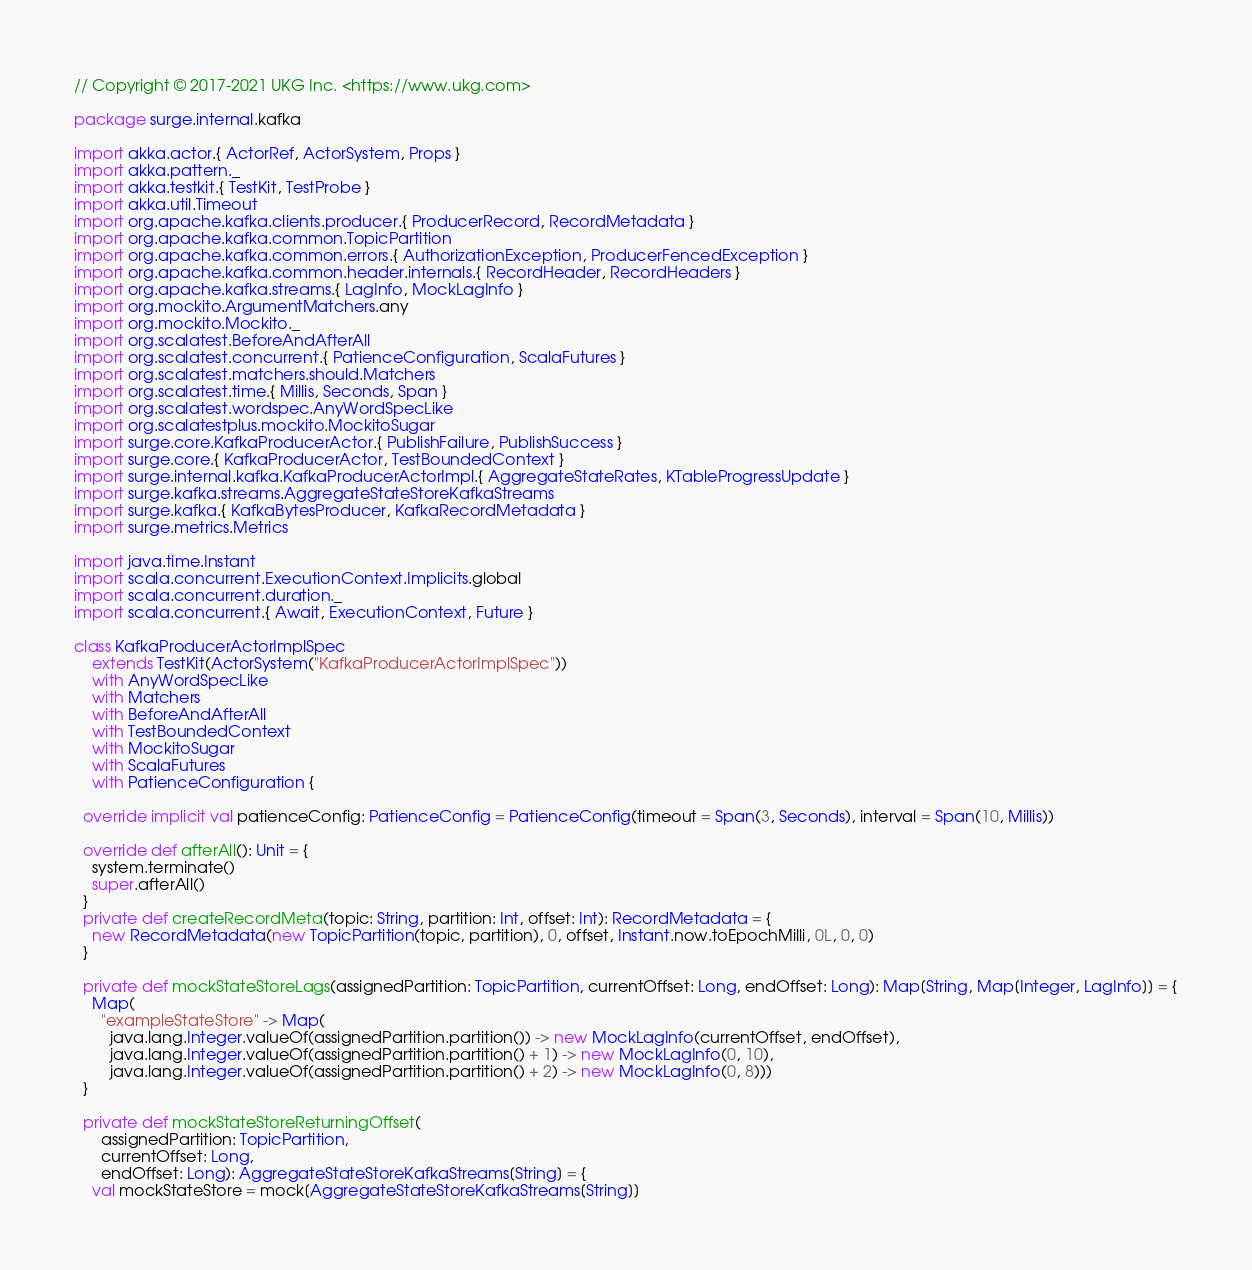<code> <loc_0><loc_0><loc_500><loc_500><_Scala_>// Copyright © 2017-2021 UKG Inc. <https://www.ukg.com>

package surge.internal.kafka

import akka.actor.{ ActorRef, ActorSystem, Props }
import akka.pattern._
import akka.testkit.{ TestKit, TestProbe }
import akka.util.Timeout
import org.apache.kafka.clients.producer.{ ProducerRecord, RecordMetadata }
import org.apache.kafka.common.TopicPartition
import org.apache.kafka.common.errors.{ AuthorizationException, ProducerFencedException }
import org.apache.kafka.common.header.internals.{ RecordHeader, RecordHeaders }
import org.apache.kafka.streams.{ LagInfo, MockLagInfo }
import org.mockito.ArgumentMatchers.any
import org.mockito.Mockito._
import org.scalatest.BeforeAndAfterAll
import org.scalatest.concurrent.{ PatienceConfiguration, ScalaFutures }
import org.scalatest.matchers.should.Matchers
import org.scalatest.time.{ Millis, Seconds, Span }
import org.scalatest.wordspec.AnyWordSpecLike
import org.scalatestplus.mockito.MockitoSugar
import surge.core.KafkaProducerActor.{ PublishFailure, PublishSuccess }
import surge.core.{ KafkaProducerActor, TestBoundedContext }
import surge.internal.kafka.KafkaProducerActorImpl.{ AggregateStateRates, KTableProgressUpdate }
import surge.kafka.streams.AggregateStateStoreKafkaStreams
import surge.kafka.{ KafkaBytesProducer, KafkaRecordMetadata }
import surge.metrics.Metrics

import java.time.Instant
import scala.concurrent.ExecutionContext.Implicits.global
import scala.concurrent.duration._
import scala.concurrent.{ Await, ExecutionContext, Future }

class KafkaProducerActorImplSpec
    extends TestKit(ActorSystem("KafkaProducerActorImplSpec"))
    with AnyWordSpecLike
    with Matchers
    with BeforeAndAfterAll
    with TestBoundedContext
    with MockitoSugar
    with ScalaFutures
    with PatienceConfiguration {

  override implicit val patienceConfig: PatienceConfig = PatienceConfig(timeout = Span(3, Seconds), interval = Span(10, Millis))

  override def afterAll(): Unit = {
    system.terminate()
    super.afterAll()
  }
  private def createRecordMeta(topic: String, partition: Int, offset: Int): RecordMetadata = {
    new RecordMetadata(new TopicPartition(topic, partition), 0, offset, Instant.now.toEpochMilli, 0L, 0, 0)
  }

  private def mockStateStoreLags(assignedPartition: TopicPartition, currentOffset: Long, endOffset: Long): Map[String, Map[Integer, LagInfo]] = {
    Map(
      "exampleStateStore" -> Map(
        java.lang.Integer.valueOf(assignedPartition.partition()) -> new MockLagInfo(currentOffset, endOffset),
        java.lang.Integer.valueOf(assignedPartition.partition() + 1) -> new MockLagInfo(0, 10),
        java.lang.Integer.valueOf(assignedPartition.partition() + 2) -> new MockLagInfo(0, 8)))
  }

  private def mockStateStoreReturningOffset(
      assignedPartition: TopicPartition,
      currentOffset: Long,
      endOffset: Long): AggregateStateStoreKafkaStreams[String] = {
    val mockStateStore = mock[AggregateStateStoreKafkaStreams[String]]</code> 